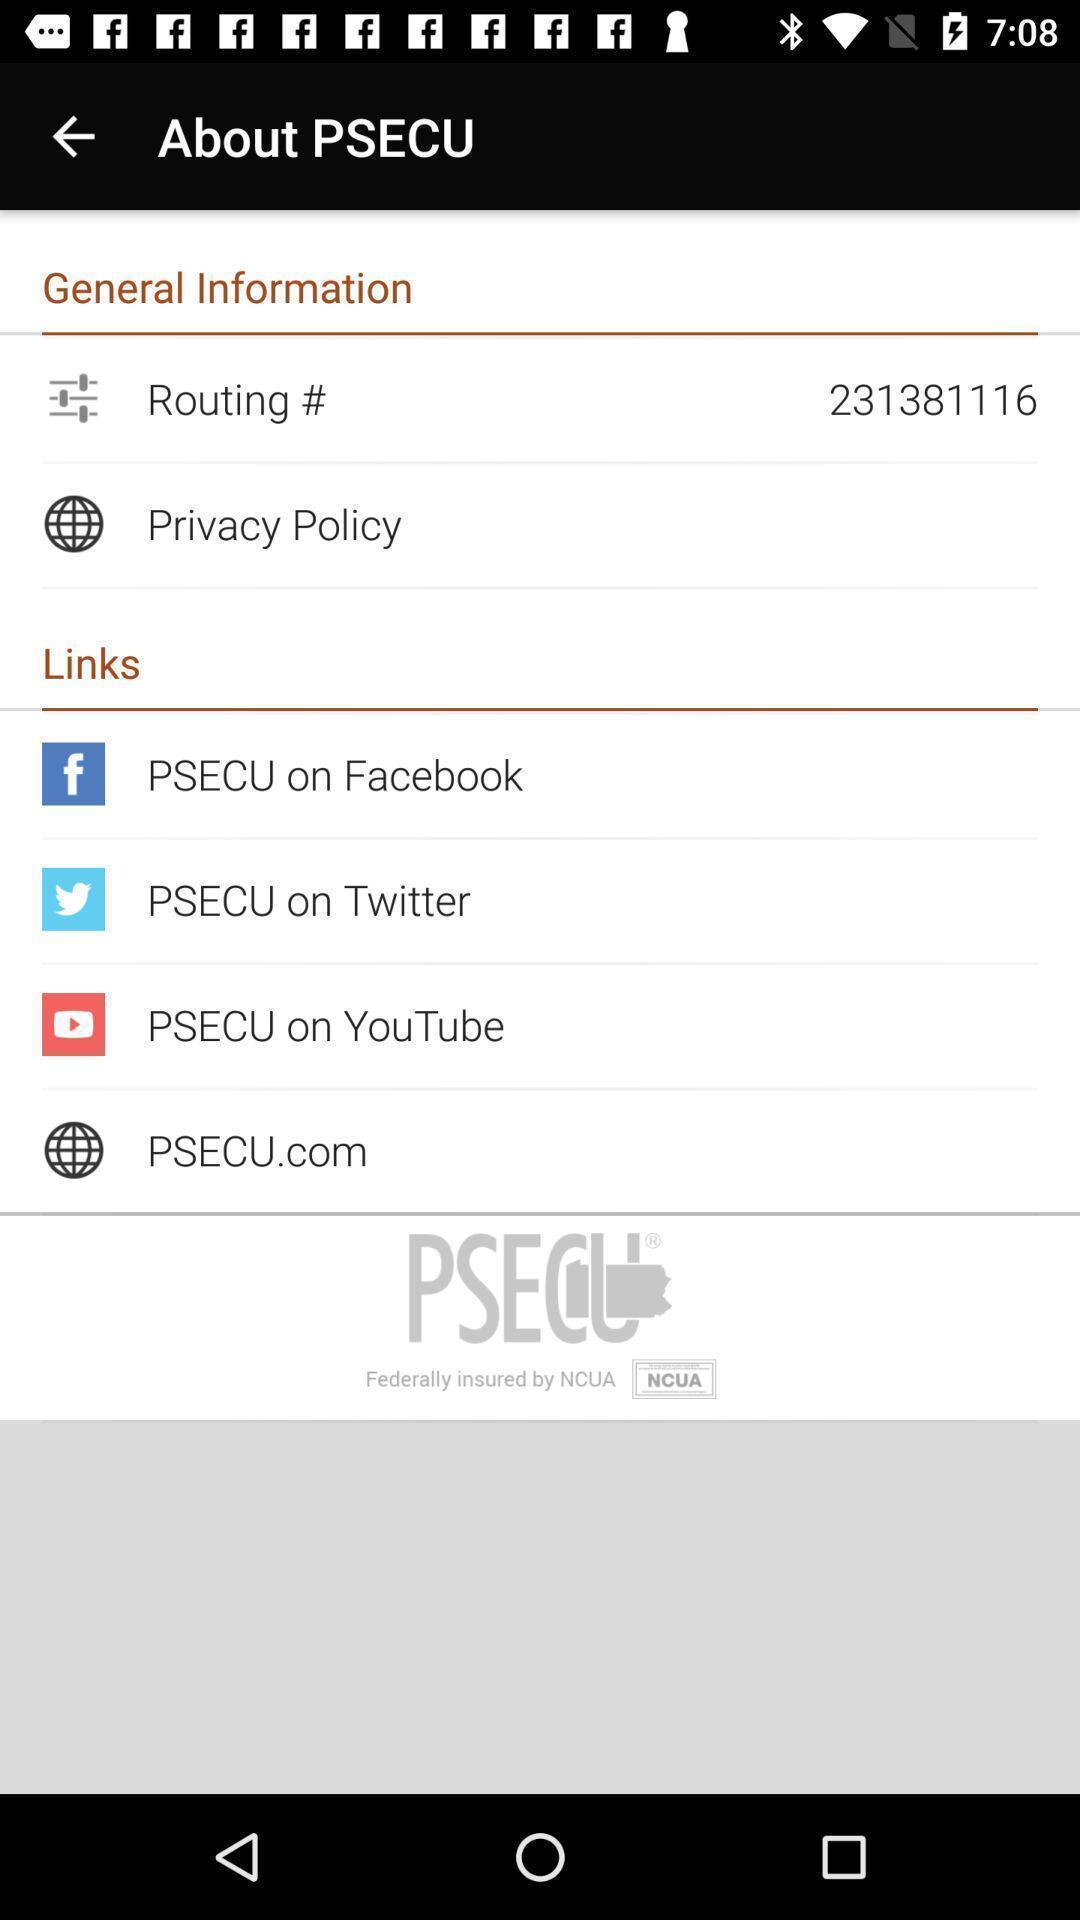Give me a narrative description of this picture. Page showing the options in about details. 